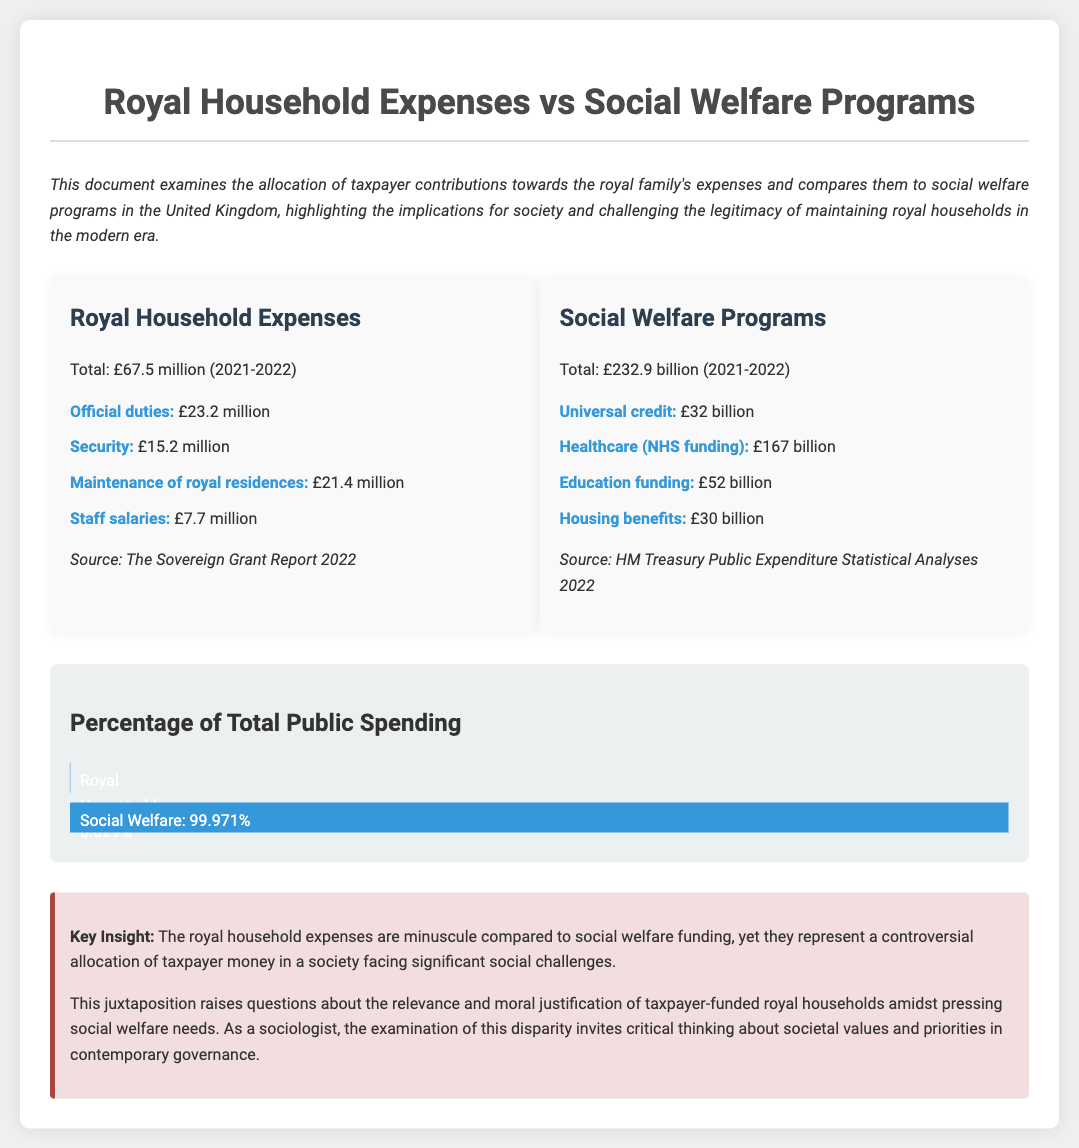What is the total amount for royal household expenses? The total royal household expenses are stated as £67.5 million for the year 2021-2022.
Answer: £67.5 million What is the allocation for healthcare in social welfare programs? Healthcare funding from the social welfare programs is listed as £167 billion.
Answer: £167 billion How much is spent on security for the royal household? The document specifies that £15.2 million is spent on security for the royal household.
Answer: £15.2 million What percentage of total public spending is represented by royal household expenses? The document indicates that royal household expenses represent 0.029% of total public spending.
Answer: 0.029% What is the total allocation for social welfare programs? The total for social welfare programs is stated as £232.9 billion for the year 2021-2022.
Answer: £232.9 billion Which social welfare program has the highest funding? The healthcare (NHS funding) is indicated to have the highest funding at £167 billion.
Answer: Healthcare (NHS funding) What is the breakdown of staff salaries in the royal household expenses? Staff salaries are listed as costing £7.7 million in royal household expenses.
Answer: £7.7 million What does the document suggest about taxpayer-funded royal households? The conclusion raises questions about the relevance and moral justification of taxpayer-funded royal households.
Answer: Relevance and moral justification What is the source of the data for royal household expenses? The royal household expenses sources are stated as The Sovereign Grant Report 2022.
Answer: The Sovereign Grant Report 2022 